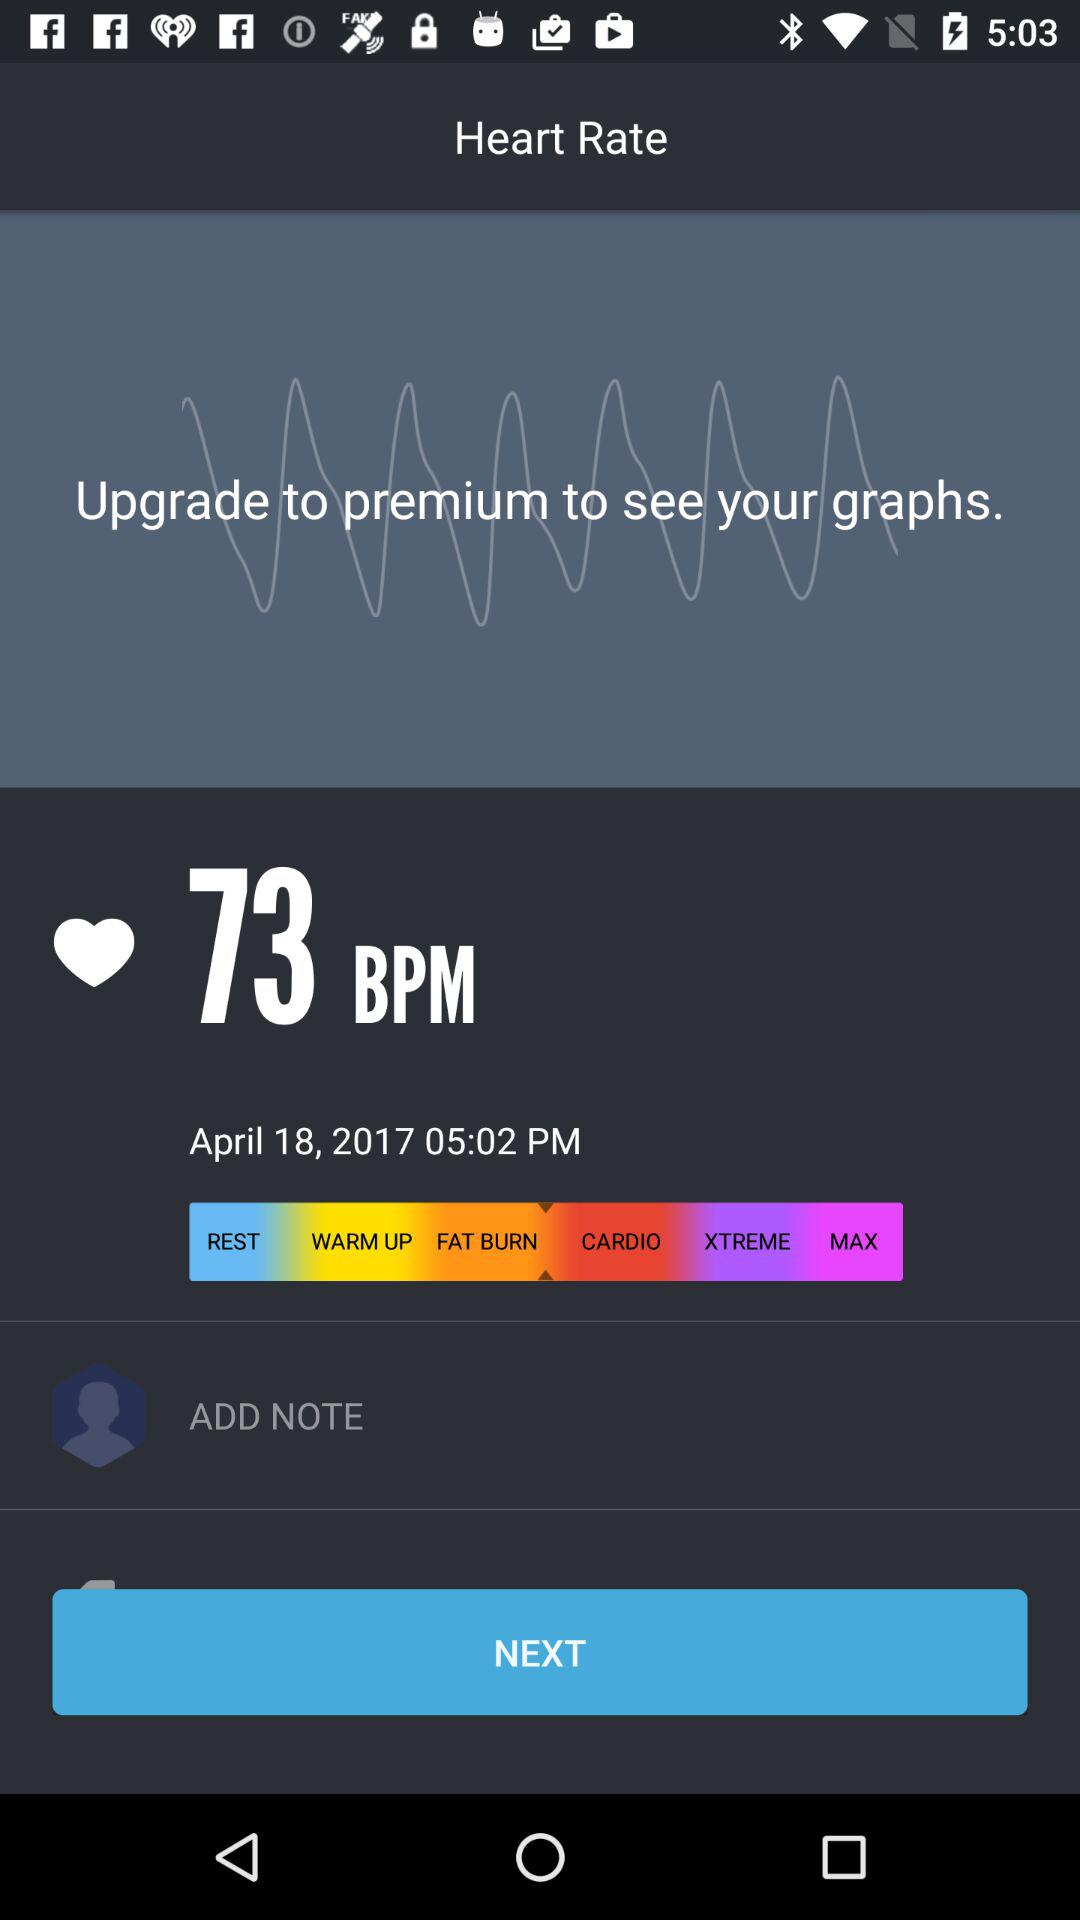How much BPM is given? The given BPM is 73. 